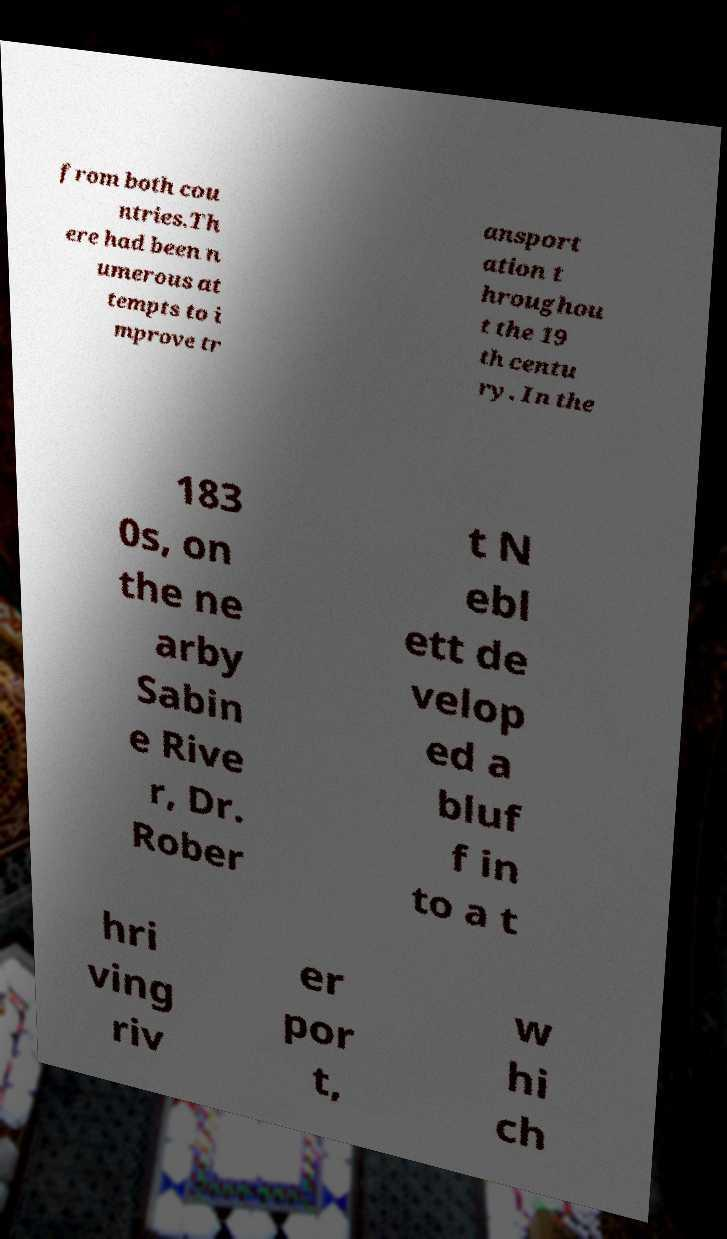I need the written content from this picture converted into text. Can you do that? from both cou ntries.Th ere had been n umerous at tempts to i mprove tr ansport ation t hroughou t the 19 th centu ry. In the 183 0s, on the ne arby Sabin e Rive r, Dr. Rober t N ebl ett de velop ed a bluf f in to a t hri ving riv er por t, w hi ch 